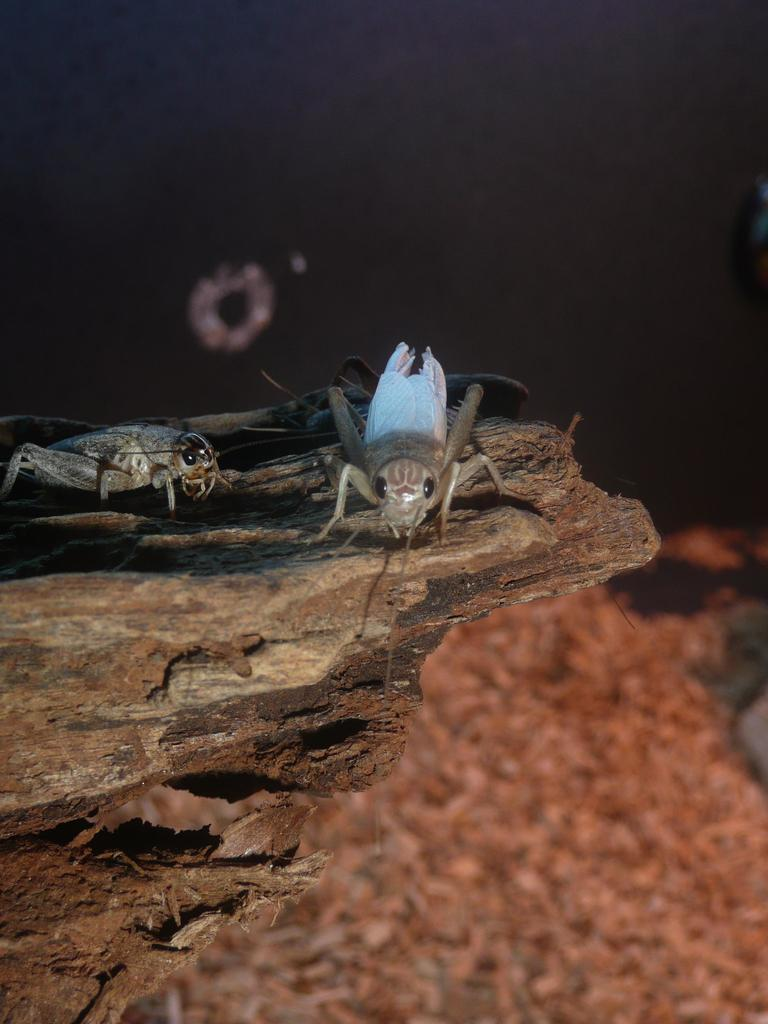What type of creatures can be seen in the image? There are insects in the image. Where are the insects located? The insects are on a wooden bark. What word is being used to measure the length of the yak in the image? There is no yak or measurement word present in the image; it only features insects on a wooden bark. 